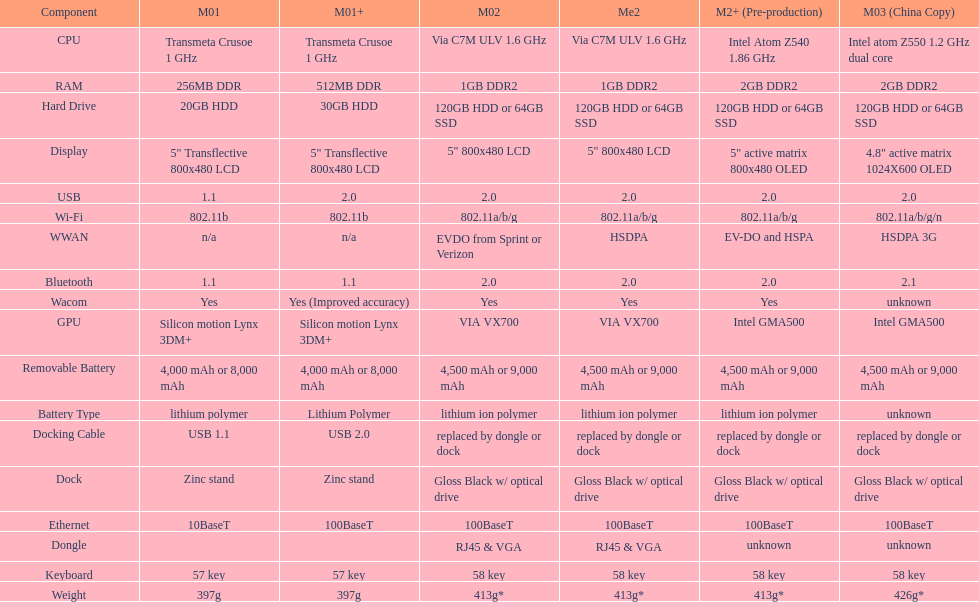The model 2 and the model 2e have what type of cpu? Via C7M ULV 1.6 GHz. 